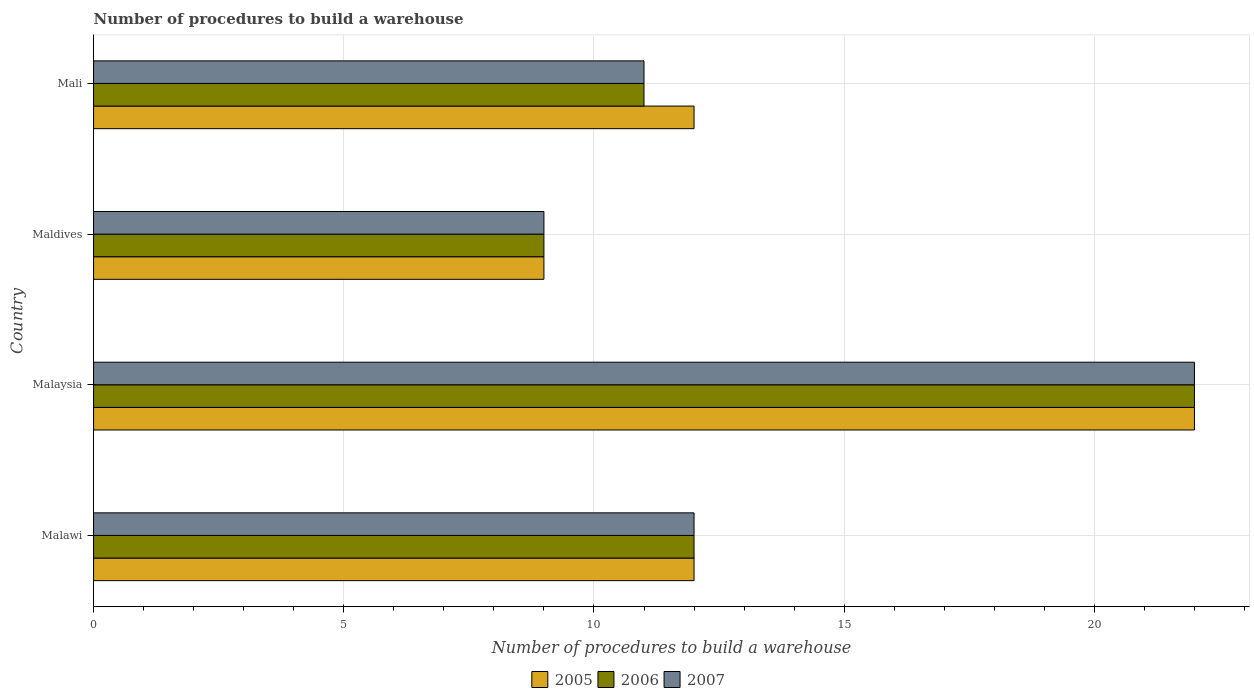How many different coloured bars are there?
Ensure brevity in your answer.  3. How many groups of bars are there?
Offer a terse response. 4. Are the number of bars per tick equal to the number of legend labels?
Offer a very short reply. Yes. Are the number of bars on each tick of the Y-axis equal?
Ensure brevity in your answer.  Yes. How many bars are there on the 2nd tick from the top?
Your answer should be very brief. 3. What is the label of the 1st group of bars from the top?
Ensure brevity in your answer.  Mali. In how many cases, is the number of bars for a given country not equal to the number of legend labels?
Provide a short and direct response. 0. What is the number of procedures to build a warehouse in in 2005 in Malaysia?
Ensure brevity in your answer.  22. In which country was the number of procedures to build a warehouse in in 2006 maximum?
Your response must be concise. Malaysia. In which country was the number of procedures to build a warehouse in in 2007 minimum?
Your response must be concise. Maldives. What is the total number of procedures to build a warehouse in in 2005 in the graph?
Offer a very short reply. 55. What is the average number of procedures to build a warehouse in in 2005 per country?
Offer a terse response. 13.75. What is the ratio of the number of procedures to build a warehouse in in 2006 in Malawi to that in Malaysia?
Give a very brief answer. 0.55. What is the difference between the highest and the second highest number of procedures to build a warehouse in in 2007?
Provide a succinct answer. 10. What does the 3rd bar from the top in Malawi represents?
Your response must be concise. 2005. What does the 3rd bar from the bottom in Mali represents?
Your answer should be very brief. 2007. How many countries are there in the graph?
Ensure brevity in your answer.  4. Are the values on the major ticks of X-axis written in scientific E-notation?
Make the answer very short. No. Does the graph contain any zero values?
Keep it short and to the point. No. Where does the legend appear in the graph?
Your response must be concise. Bottom center. What is the title of the graph?
Make the answer very short. Number of procedures to build a warehouse. Does "1970" appear as one of the legend labels in the graph?
Give a very brief answer. No. What is the label or title of the X-axis?
Keep it short and to the point. Number of procedures to build a warehouse. What is the label or title of the Y-axis?
Ensure brevity in your answer.  Country. What is the Number of procedures to build a warehouse of 2005 in Malawi?
Provide a succinct answer. 12. What is the Number of procedures to build a warehouse in 2005 in Malaysia?
Keep it short and to the point. 22. What is the Number of procedures to build a warehouse in 2006 in Malaysia?
Offer a very short reply. 22. What is the Number of procedures to build a warehouse of 2007 in Malaysia?
Make the answer very short. 22. What is the Number of procedures to build a warehouse of 2006 in Maldives?
Keep it short and to the point. 9. What is the Number of procedures to build a warehouse of 2007 in Mali?
Your answer should be very brief. 11. Across all countries, what is the maximum Number of procedures to build a warehouse in 2007?
Make the answer very short. 22. What is the total Number of procedures to build a warehouse of 2006 in the graph?
Offer a terse response. 54. What is the difference between the Number of procedures to build a warehouse of 2006 in Malawi and that in Maldives?
Offer a very short reply. 3. What is the difference between the Number of procedures to build a warehouse in 2007 in Malawi and that in Maldives?
Ensure brevity in your answer.  3. What is the difference between the Number of procedures to build a warehouse of 2006 in Malaysia and that in Maldives?
Your answer should be compact. 13. What is the difference between the Number of procedures to build a warehouse in 2007 in Malaysia and that in Mali?
Ensure brevity in your answer.  11. What is the difference between the Number of procedures to build a warehouse of 2006 in Maldives and that in Mali?
Provide a short and direct response. -2. What is the difference between the Number of procedures to build a warehouse of 2007 in Maldives and that in Mali?
Give a very brief answer. -2. What is the difference between the Number of procedures to build a warehouse of 2006 in Malawi and the Number of procedures to build a warehouse of 2007 in Malaysia?
Your answer should be very brief. -10. What is the difference between the Number of procedures to build a warehouse of 2006 in Malawi and the Number of procedures to build a warehouse of 2007 in Maldives?
Your answer should be very brief. 3. What is the difference between the Number of procedures to build a warehouse of 2005 in Malawi and the Number of procedures to build a warehouse of 2007 in Mali?
Your response must be concise. 1. What is the difference between the Number of procedures to build a warehouse in 2006 in Malawi and the Number of procedures to build a warehouse in 2007 in Mali?
Your answer should be very brief. 1. What is the difference between the Number of procedures to build a warehouse of 2005 in Malaysia and the Number of procedures to build a warehouse of 2006 in Maldives?
Give a very brief answer. 13. What is the difference between the Number of procedures to build a warehouse in 2005 in Malaysia and the Number of procedures to build a warehouse in 2006 in Mali?
Provide a succinct answer. 11. What is the difference between the Number of procedures to build a warehouse in 2005 in Malaysia and the Number of procedures to build a warehouse in 2007 in Mali?
Provide a succinct answer. 11. What is the difference between the Number of procedures to build a warehouse in 2006 in Malaysia and the Number of procedures to build a warehouse in 2007 in Mali?
Your answer should be compact. 11. What is the difference between the Number of procedures to build a warehouse of 2005 in Maldives and the Number of procedures to build a warehouse of 2006 in Mali?
Keep it short and to the point. -2. What is the difference between the Number of procedures to build a warehouse of 2005 in Maldives and the Number of procedures to build a warehouse of 2007 in Mali?
Keep it short and to the point. -2. What is the difference between the Number of procedures to build a warehouse of 2006 in Maldives and the Number of procedures to build a warehouse of 2007 in Mali?
Your answer should be very brief. -2. What is the average Number of procedures to build a warehouse in 2005 per country?
Make the answer very short. 13.75. What is the average Number of procedures to build a warehouse of 2006 per country?
Give a very brief answer. 13.5. What is the average Number of procedures to build a warehouse of 2007 per country?
Keep it short and to the point. 13.5. What is the difference between the Number of procedures to build a warehouse in 2005 and Number of procedures to build a warehouse in 2006 in Malaysia?
Offer a very short reply. 0. What is the difference between the Number of procedures to build a warehouse of 2006 and Number of procedures to build a warehouse of 2007 in Malaysia?
Offer a very short reply. 0. What is the difference between the Number of procedures to build a warehouse of 2005 and Number of procedures to build a warehouse of 2006 in Maldives?
Ensure brevity in your answer.  0. What is the difference between the Number of procedures to build a warehouse in 2005 and Number of procedures to build a warehouse in 2007 in Maldives?
Offer a terse response. 0. What is the difference between the Number of procedures to build a warehouse of 2005 and Number of procedures to build a warehouse of 2006 in Mali?
Provide a short and direct response. 1. What is the difference between the Number of procedures to build a warehouse in 2005 and Number of procedures to build a warehouse in 2007 in Mali?
Provide a succinct answer. 1. What is the difference between the Number of procedures to build a warehouse of 2006 and Number of procedures to build a warehouse of 2007 in Mali?
Keep it short and to the point. 0. What is the ratio of the Number of procedures to build a warehouse in 2005 in Malawi to that in Malaysia?
Offer a very short reply. 0.55. What is the ratio of the Number of procedures to build a warehouse in 2006 in Malawi to that in Malaysia?
Your answer should be very brief. 0.55. What is the ratio of the Number of procedures to build a warehouse in 2007 in Malawi to that in Malaysia?
Your answer should be compact. 0.55. What is the ratio of the Number of procedures to build a warehouse of 2005 in Malawi to that in Maldives?
Give a very brief answer. 1.33. What is the ratio of the Number of procedures to build a warehouse of 2006 in Malawi to that in Maldives?
Your answer should be compact. 1.33. What is the ratio of the Number of procedures to build a warehouse of 2006 in Malawi to that in Mali?
Provide a short and direct response. 1.09. What is the ratio of the Number of procedures to build a warehouse in 2005 in Malaysia to that in Maldives?
Your answer should be very brief. 2.44. What is the ratio of the Number of procedures to build a warehouse in 2006 in Malaysia to that in Maldives?
Offer a terse response. 2.44. What is the ratio of the Number of procedures to build a warehouse in 2007 in Malaysia to that in Maldives?
Your answer should be compact. 2.44. What is the ratio of the Number of procedures to build a warehouse of 2005 in Malaysia to that in Mali?
Your answer should be compact. 1.83. What is the ratio of the Number of procedures to build a warehouse in 2006 in Malaysia to that in Mali?
Your response must be concise. 2. What is the ratio of the Number of procedures to build a warehouse in 2007 in Malaysia to that in Mali?
Offer a terse response. 2. What is the ratio of the Number of procedures to build a warehouse of 2006 in Maldives to that in Mali?
Give a very brief answer. 0.82. What is the ratio of the Number of procedures to build a warehouse in 2007 in Maldives to that in Mali?
Offer a terse response. 0.82. What is the difference between the highest and the lowest Number of procedures to build a warehouse of 2007?
Ensure brevity in your answer.  13. 